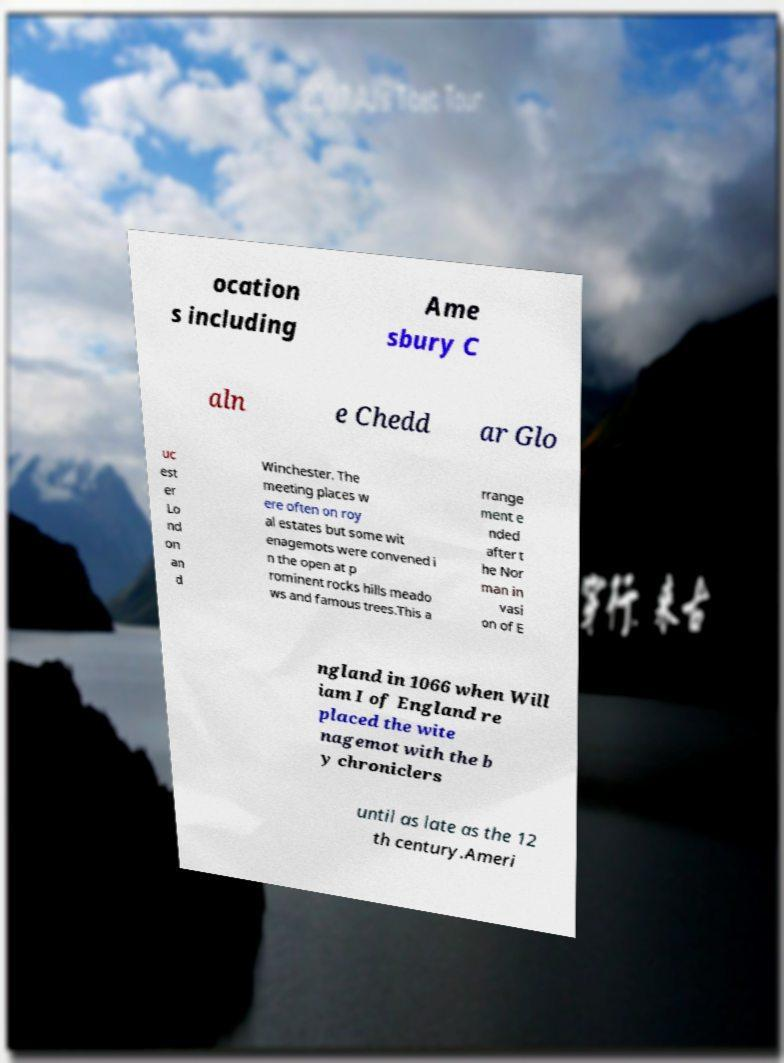Please identify and transcribe the text found in this image. ocation s including Ame sbury C aln e Chedd ar Glo uc est er Lo nd on an d Winchester. The meeting places w ere often on roy al estates but some wit enagemots were convened i n the open at p rominent rocks hills meado ws and famous trees.This a rrange ment e nded after t he Nor man in vasi on of E ngland in 1066 when Will iam I of England re placed the wite nagemot with the b y chroniclers until as late as the 12 th century.Ameri 